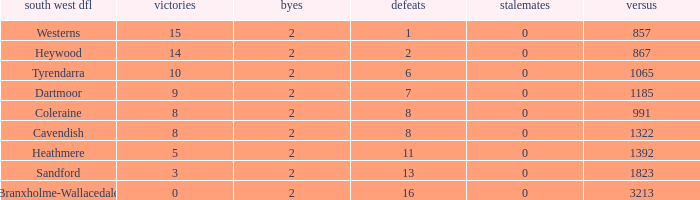Which Losses have a South West DFL of branxholme-wallacedale, and less than 2 Byes? None. 